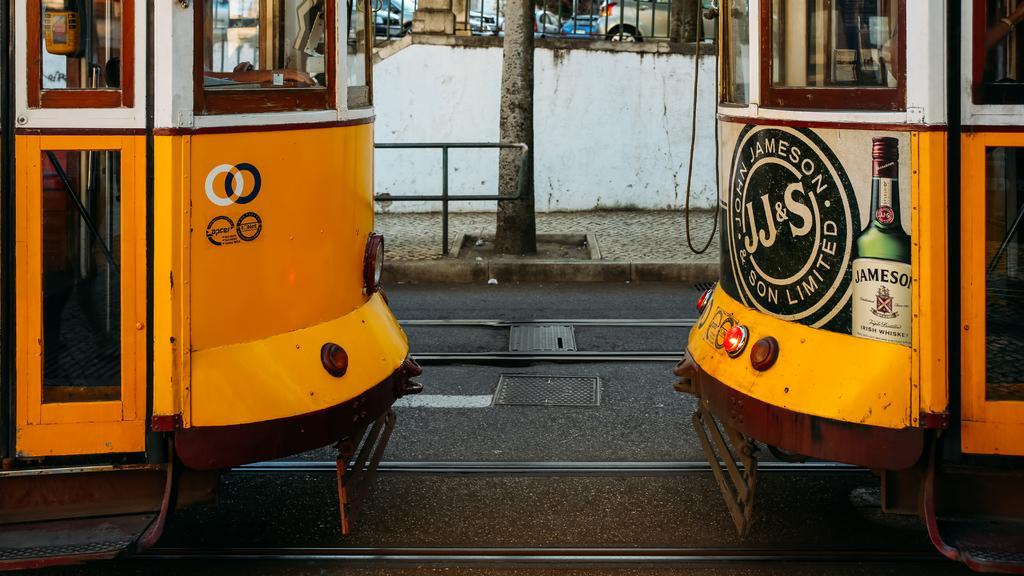Describe this image in one or two sentences. In this image we can see the locomotives on the track. We can also see a manhole on the road, the bark of a tree, a metal fence, a wall and some cars parked aside. 